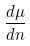Convert formula to latex. <formula><loc_0><loc_0><loc_500><loc_500>\frac { d \mu } { d n }</formula> 